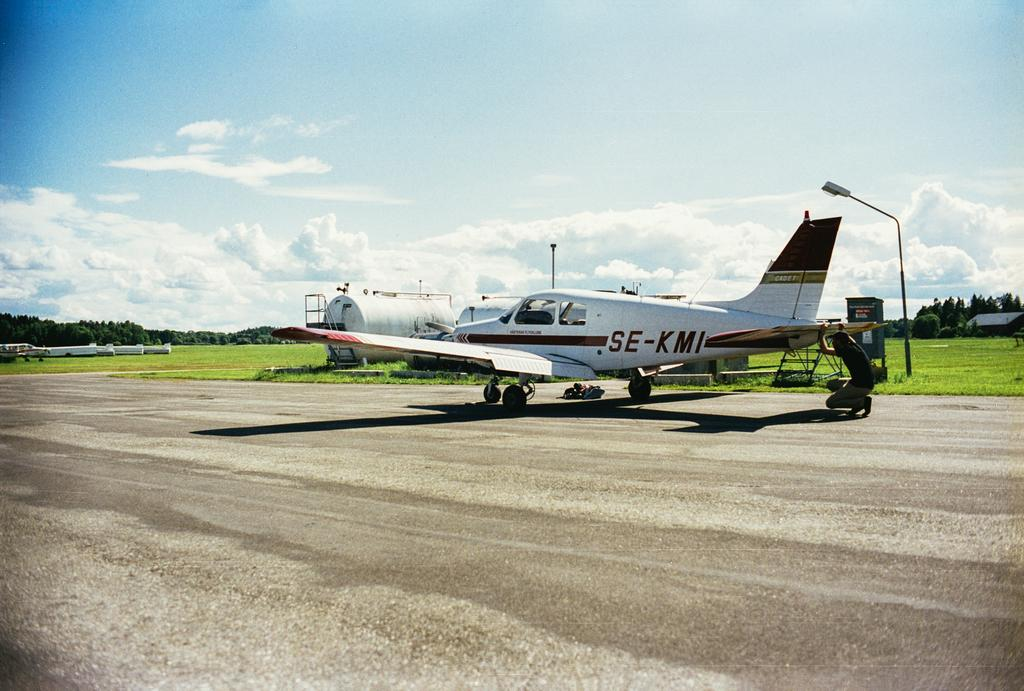<image>
Give a short and clear explanation of the subsequent image. A small plane sitting on a runway that has the reg number SE-KMI. 